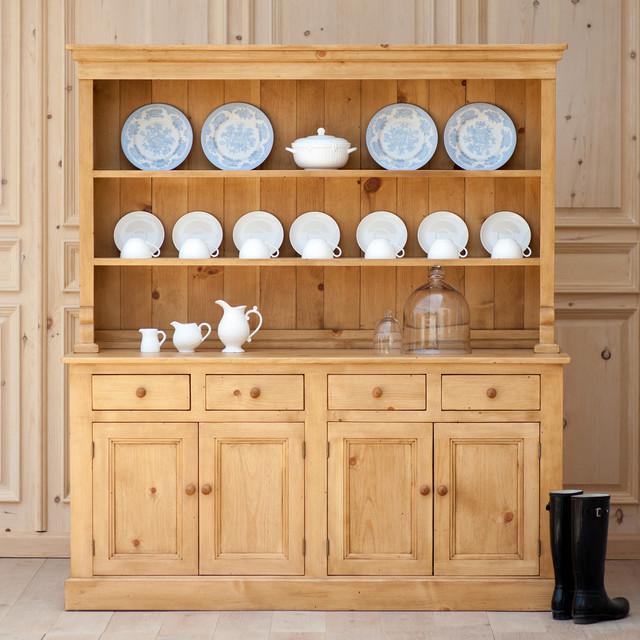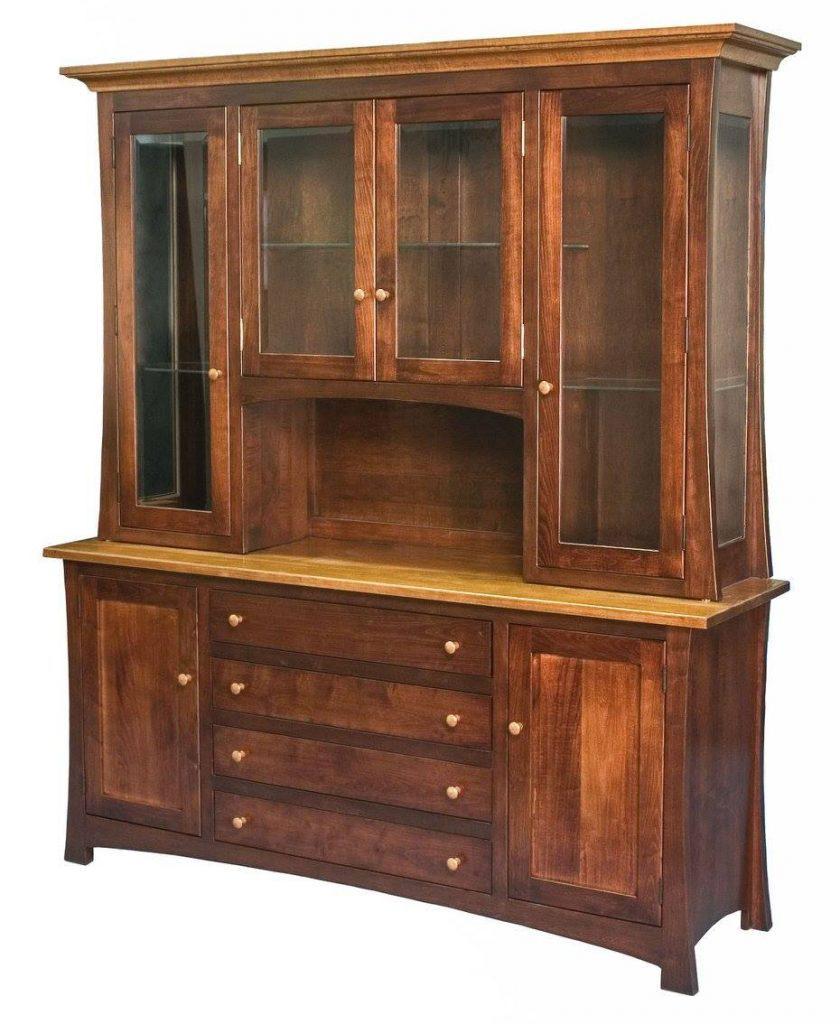The first image is the image on the left, the second image is the image on the right. Examine the images to the left and right. Is the description "A brown wood cabinet has slender legs and arch shapes on the glass-fronted cabinet doors." accurate? Answer yes or no. No. The first image is the image on the left, the second image is the image on the right. Evaluate the accuracy of this statement regarding the images: "A brown hutch is empty in the right image.". Is it true? Answer yes or no. Yes. 